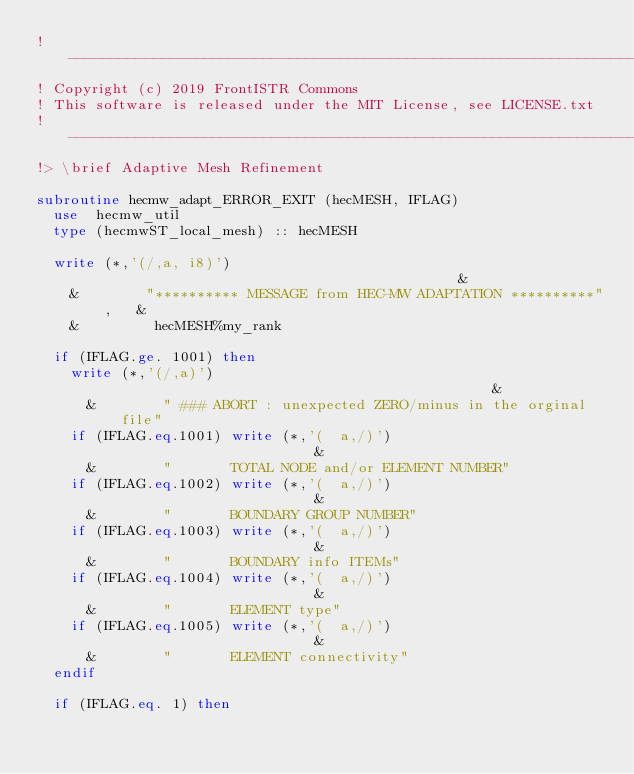<code> <loc_0><loc_0><loc_500><loc_500><_FORTRAN_>!-------------------------------------------------------------------------------
! Copyright (c) 2019 FrontISTR Commons
! This software is released under the MIT License, see LICENSE.txt
!-------------------------------------------------------------------------------
!> \brief Adaptive Mesh Refinement

subroutine hecmw_adapt_ERROR_EXIT (hecMESH, IFLAG)
  use  hecmw_util
  type (hecmwST_local_mesh) :: hecMESH

  write (*,'(/,a, i8)')                                             &
    &        "********** MESSAGE from HEC-MW ADAPTATION **********",   &
    &         hecMESH%my_rank

  if (IFLAG.ge. 1001) then
    write (*,'(/,a)')                                               &
      &        " ### ABORT : unexpected ZERO/minus in the orginal file"
    if (IFLAG.eq.1001) write (*,'(  a,/)')                          &
      &        "       TOTAL NODE and/or ELEMENT NUMBER"
    if (IFLAG.eq.1002) write (*,'(  a,/)')                          &
      &        "       BOUNDARY GROUP NUMBER"
    if (IFLAG.eq.1003) write (*,'(  a,/)')                          &
      &        "       BOUNDARY info ITEMs"
    if (IFLAG.eq.1004) write (*,'(  a,/)')                          &
      &        "       ELEMENT type"
    if (IFLAG.eq.1005) write (*,'(  a,/)')                          &
      &        "       ELEMENT connectivity"
  endif

  if (IFLAG.eq. 1) then</code> 